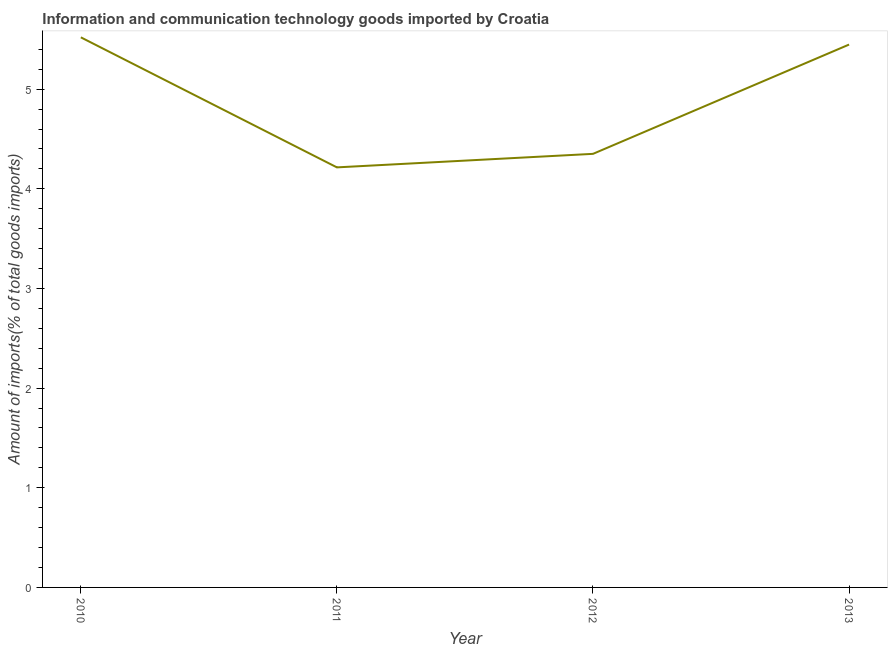What is the amount of ict goods imports in 2010?
Your answer should be very brief. 5.52. Across all years, what is the maximum amount of ict goods imports?
Make the answer very short. 5.52. Across all years, what is the minimum amount of ict goods imports?
Your answer should be compact. 4.21. In which year was the amount of ict goods imports maximum?
Give a very brief answer. 2010. What is the sum of the amount of ict goods imports?
Make the answer very short. 19.53. What is the difference between the amount of ict goods imports in 2011 and 2013?
Offer a very short reply. -1.23. What is the average amount of ict goods imports per year?
Provide a succinct answer. 4.88. What is the median amount of ict goods imports?
Your answer should be very brief. 4.9. In how many years, is the amount of ict goods imports greater than 3 %?
Keep it short and to the point. 4. Do a majority of the years between 2011 and 2012 (inclusive) have amount of ict goods imports greater than 4 %?
Offer a very short reply. Yes. What is the ratio of the amount of ict goods imports in 2010 to that in 2012?
Your response must be concise. 1.27. Is the amount of ict goods imports in 2010 less than that in 2012?
Provide a succinct answer. No. What is the difference between the highest and the second highest amount of ict goods imports?
Your answer should be compact. 0.07. Is the sum of the amount of ict goods imports in 2010 and 2012 greater than the maximum amount of ict goods imports across all years?
Keep it short and to the point. Yes. What is the difference between the highest and the lowest amount of ict goods imports?
Keep it short and to the point. 1.3. How many years are there in the graph?
Ensure brevity in your answer.  4. Are the values on the major ticks of Y-axis written in scientific E-notation?
Offer a terse response. No. What is the title of the graph?
Offer a terse response. Information and communication technology goods imported by Croatia. What is the label or title of the X-axis?
Offer a terse response. Year. What is the label or title of the Y-axis?
Offer a very short reply. Amount of imports(% of total goods imports). What is the Amount of imports(% of total goods imports) of 2010?
Provide a short and direct response. 5.52. What is the Amount of imports(% of total goods imports) in 2011?
Your response must be concise. 4.21. What is the Amount of imports(% of total goods imports) in 2012?
Provide a short and direct response. 4.35. What is the Amount of imports(% of total goods imports) of 2013?
Your response must be concise. 5.45. What is the difference between the Amount of imports(% of total goods imports) in 2010 and 2011?
Your answer should be compact. 1.3. What is the difference between the Amount of imports(% of total goods imports) in 2010 and 2012?
Keep it short and to the point. 1.17. What is the difference between the Amount of imports(% of total goods imports) in 2010 and 2013?
Offer a terse response. 0.07. What is the difference between the Amount of imports(% of total goods imports) in 2011 and 2012?
Ensure brevity in your answer.  -0.14. What is the difference between the Amount of imports(% of total goods imports) in 2011 and 2013?
Keep it short and to the point. -1.23. What is the difference between the Amount of imports(% of total goods imports) in 2012 and 2013?
Provide a succinct answer. -1.1. What is the ratio of the Amount of imports(% of total goods imports) in 2010 to that in 2011?
Your response must be concise. 1.31. What is the ratio of the Amount of imports(% of total goods imports) in 2010 to that in 2012?
Your response must be concise. 1.27. What is the ratio of the Amount of imports(% of total goods imports) in 2010 to that in 2013?
Ensure brevity in your answer.  1.01. What is the ratio of the Amount of imports(% of total goods imports) in 2011 to that in 2012?
Offer a terse response. 0.97. What is the ratio of the Amount of imports(% of total goods imports) in 2011 to that in 2013?
Provide a short and direct response. 0.77. What is the ratio of the Amount of imports(% of total goods imports) in 2012 to that in 2013?
Keep it short and to the point. 0.8. 